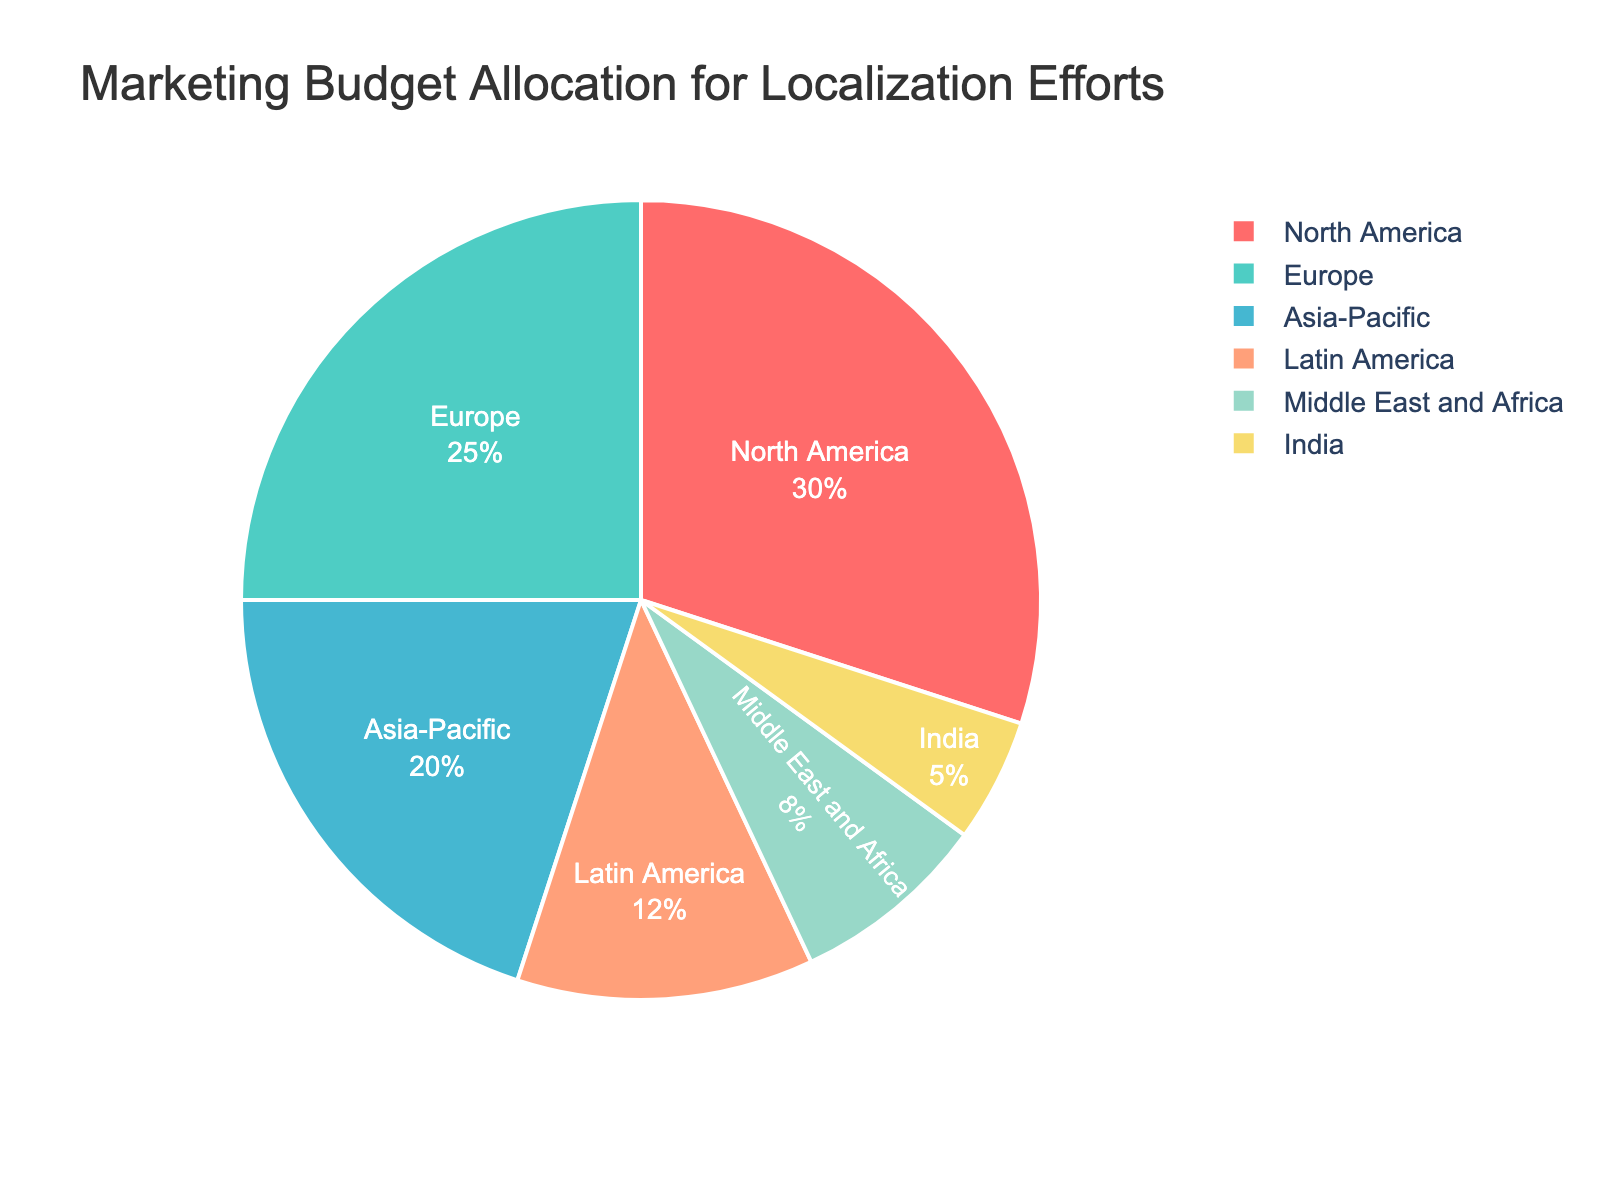What percent of the total budget is allocated to Europe? Locate the section of the pie chart labeled 'Europe' and observe the percentage displayed within that section.
Answer: 25% Which region receives the least amount of the budget? Scan the pie chart sections for the smallest slice, which is labeled 'India' with the smallest percentage.
Answer: India How much more budget is allocated to North America compared to India? Identify the budget allocation for North America (30) and India (5). Subtract India's percentage from North America's percentage: 30 - 5.
Answer: 25 Are the combined allocations for Latin America and Middle East and Africa greater than Asia-Pacific? Add the percentages for Latin America (12) and Middle East and Africa (8): 12 + 8 = 20. Compare this sum to Asia-Pacific's allocation (20).
Answer: No What is the visual attribute of the section representing Latin America? Locate the section labeled 'Latin America' and describe the visual aspects. It is a specific color (#FFA07A) and has a visible percentage inside.
Answer: Light salmon color Which region has the second-highest budget allocation? Look for the section with the second-largest slice, labeled 'Europe'.
Answer: Europe What is the difference in percentage between Asia-Pacific and Latin America? Locate the sections labeled 'Asia-Pacific' (20) and 'Latin America' (12). Subtract Latin America's allocation from Asia-Pacific's: 20 - 12.
Answer: 8 What fraction of the total budget is allocated to Middle East and Africa? Observe the percentage for 'Middle East and Africa' (8%). Convert this percentage to a fraction: 8/100 = 2/25.
Answer: 2/25 If the total budget is $1,000,000, how much is allocated to North America? Observe North America's percentage allocation (30%). Calculate the allocation: 30% of $1,000,000 = 0.30 * $1,000,000.
Answer: $300,000 